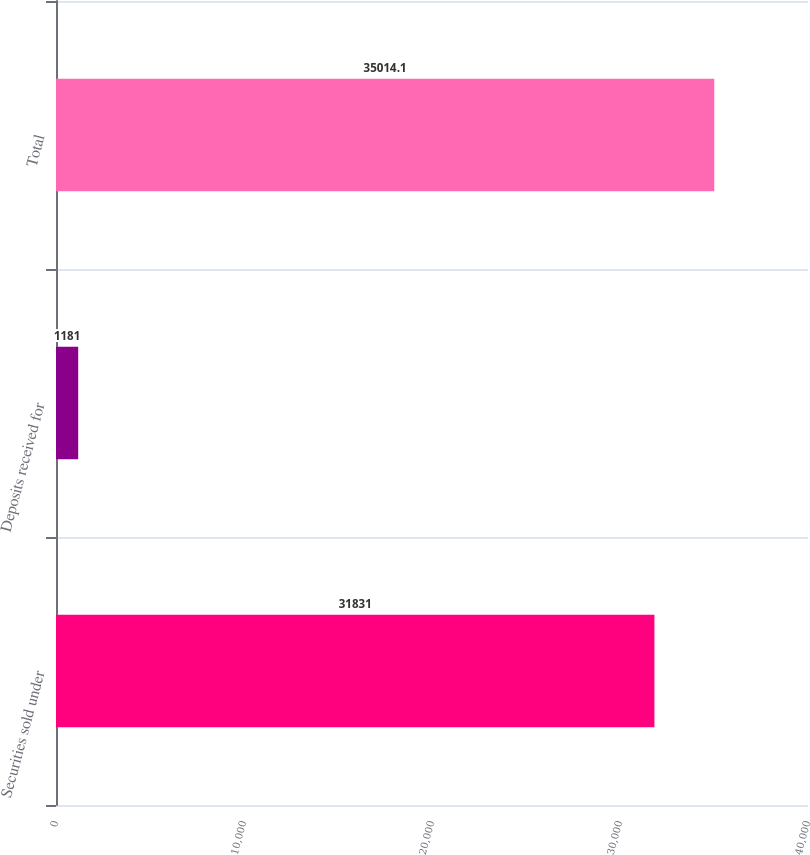Convert chart to OTSL. <chart><loc_0><loc_0><loc_500><loc_500><bar_chart><fcel>Securities sold under<fcel>Deposits received for<fcel>Total<nl><fcel>31831<fcel>1181<fcel>35014.1<nl></chart> 